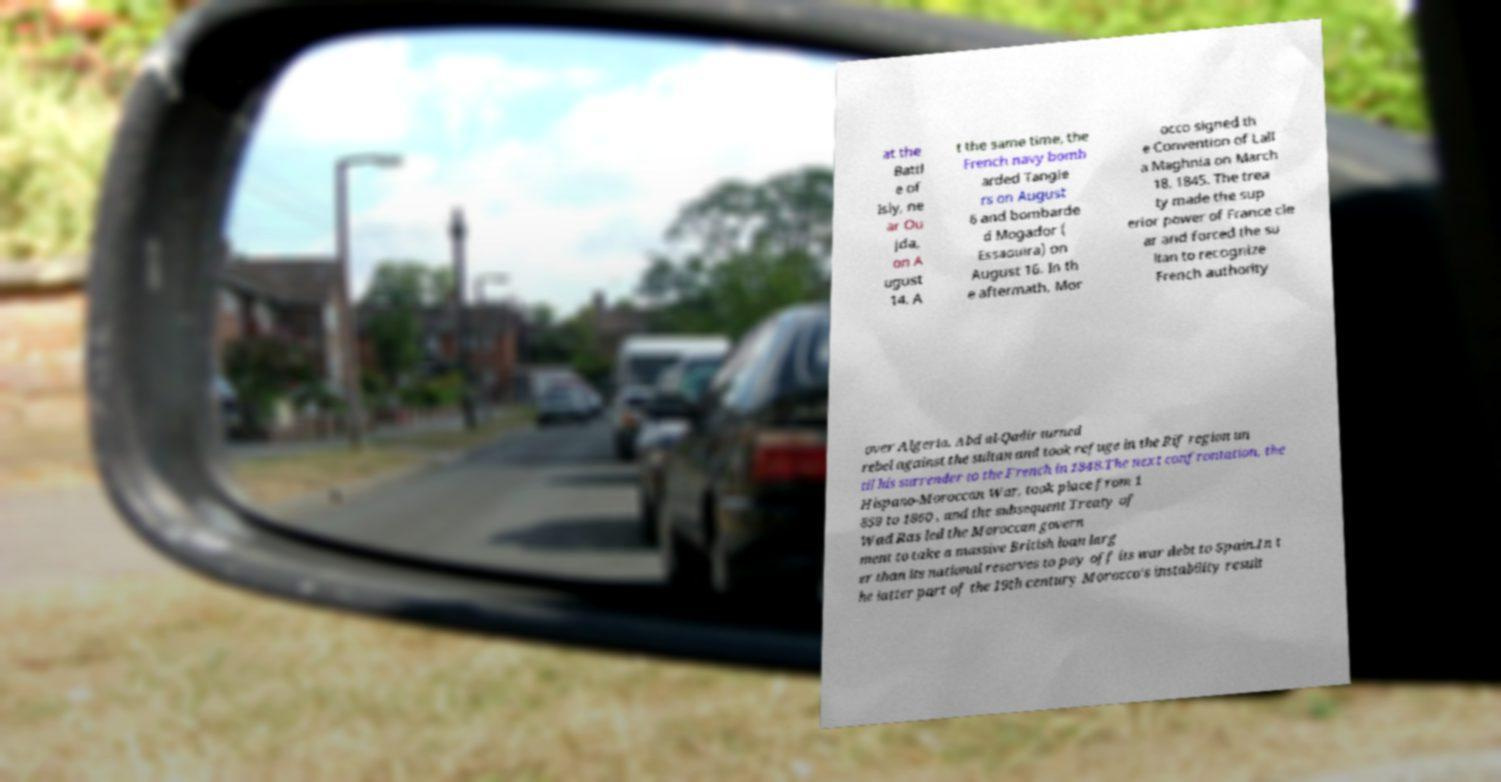Can you accurately transcribe the text from the provided image for me? at the Battl e of Isly, ne ar Ou jda, on A ugust 14. A t the same time, the French navy bomb arded Tangie rs on August 6 and bombarde d Mogador ( Essaouira) on August 16. In th e aftermath, Mor occo signed th e Convention of Lall a Maghnia on March 18, 1845. The trea ty made the sup erior power of France cle ar and forced the su ltan to recognize French authority over Algeria. Abd al-Qadir turned rebel against the sultan and took refuge in the Rif region un til his surrender to the French in 1848.The next confrontation, the Hispano-Moroccan War, took place from 1 859 to 1860 , and the subsequent Treaty of Wad Ras led the Moroccan govern ment to take a massive British loan larg er than its national reserves to pay off its war debt to Spain.In t he latter part of the 19th century Morocco's instability result 